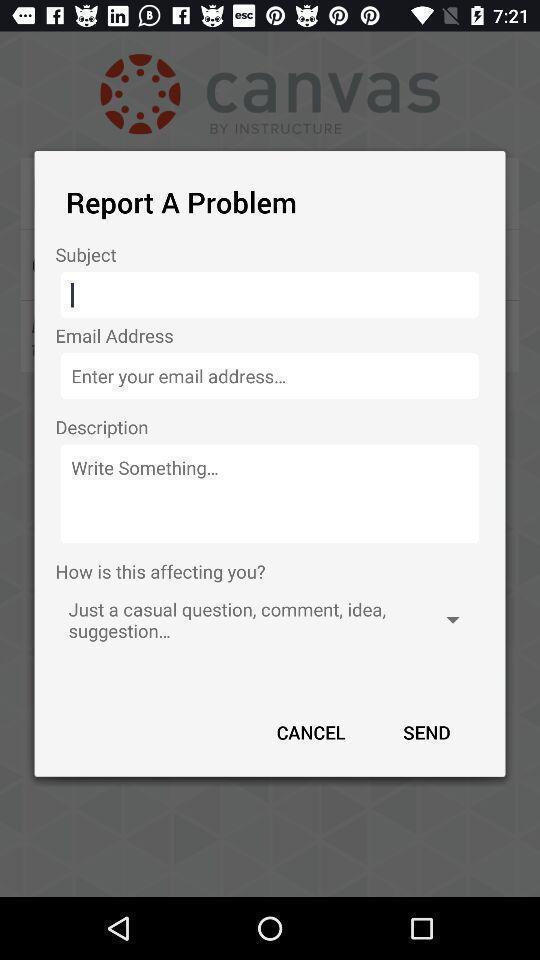Tell me what you see in this picture. Pop-up displaying to report a problem. 